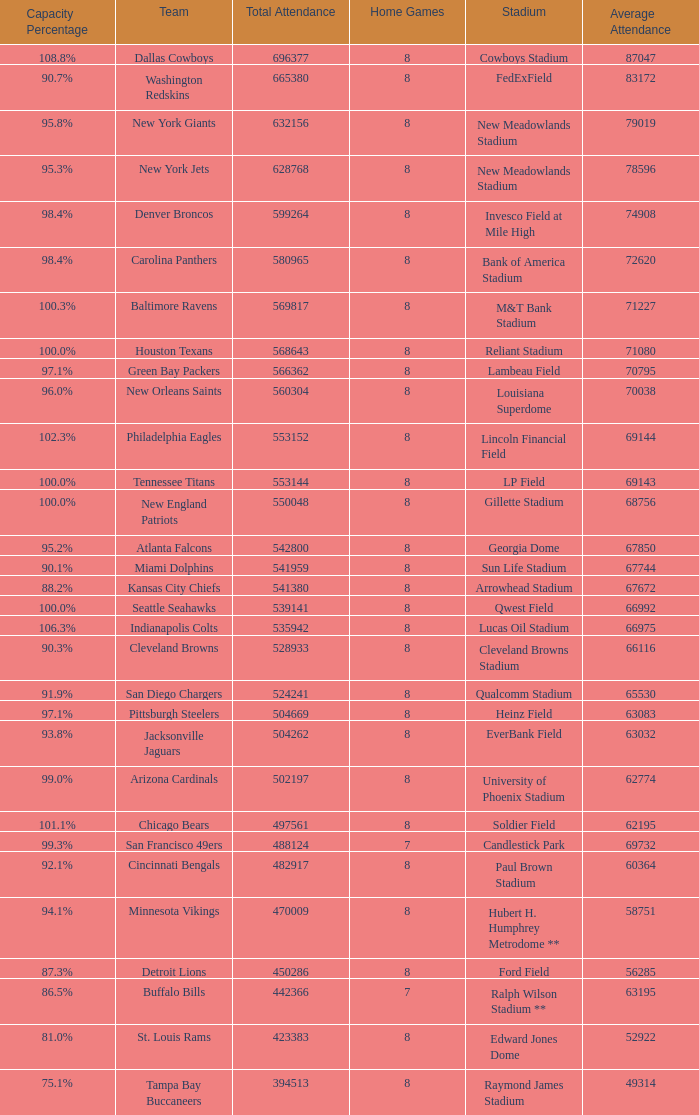How many teams had a 99.3% capacity rating? 1.0. 